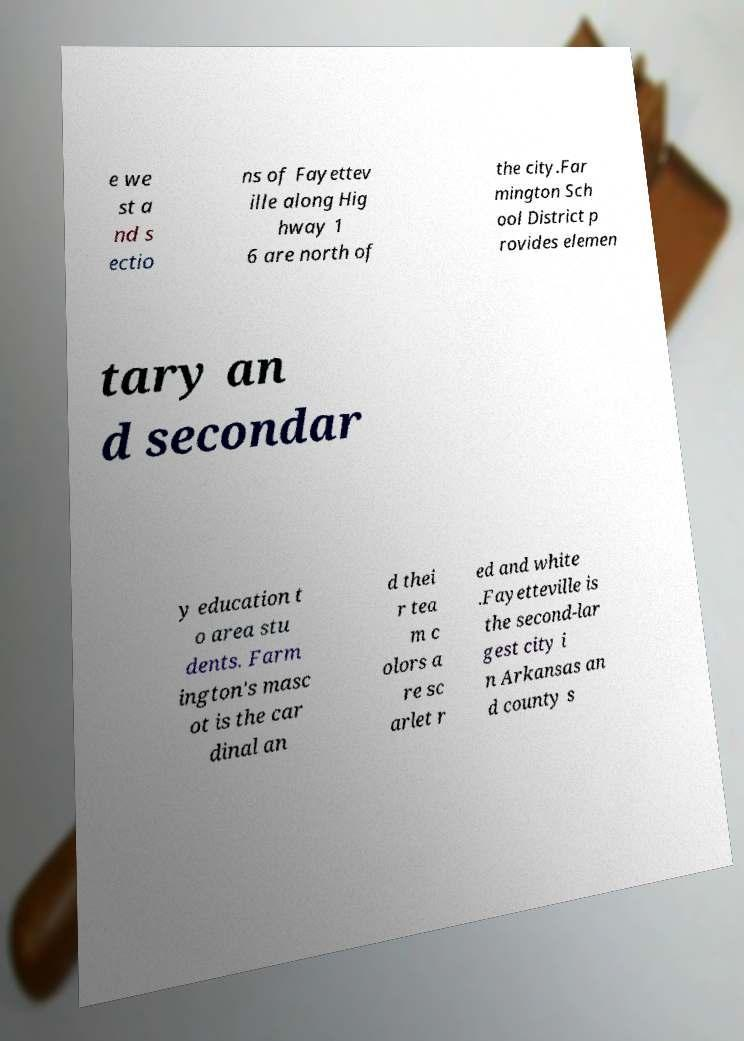What messages or text are displayed in this image? I need them in a readable, typed format. e we st a nd s ectio ns of Fayettev ille along Hig hway 1 6 are north of the city.Far mington Sch ool District p rovides elemen tary an d secondar y education t o area stu dents. Farm ington's masc ot is the car dinal an d thei r tea m c olors a re sc arlet r ed and white .Fayetteville is the second-lar gest city i n Arkansas an d county s 